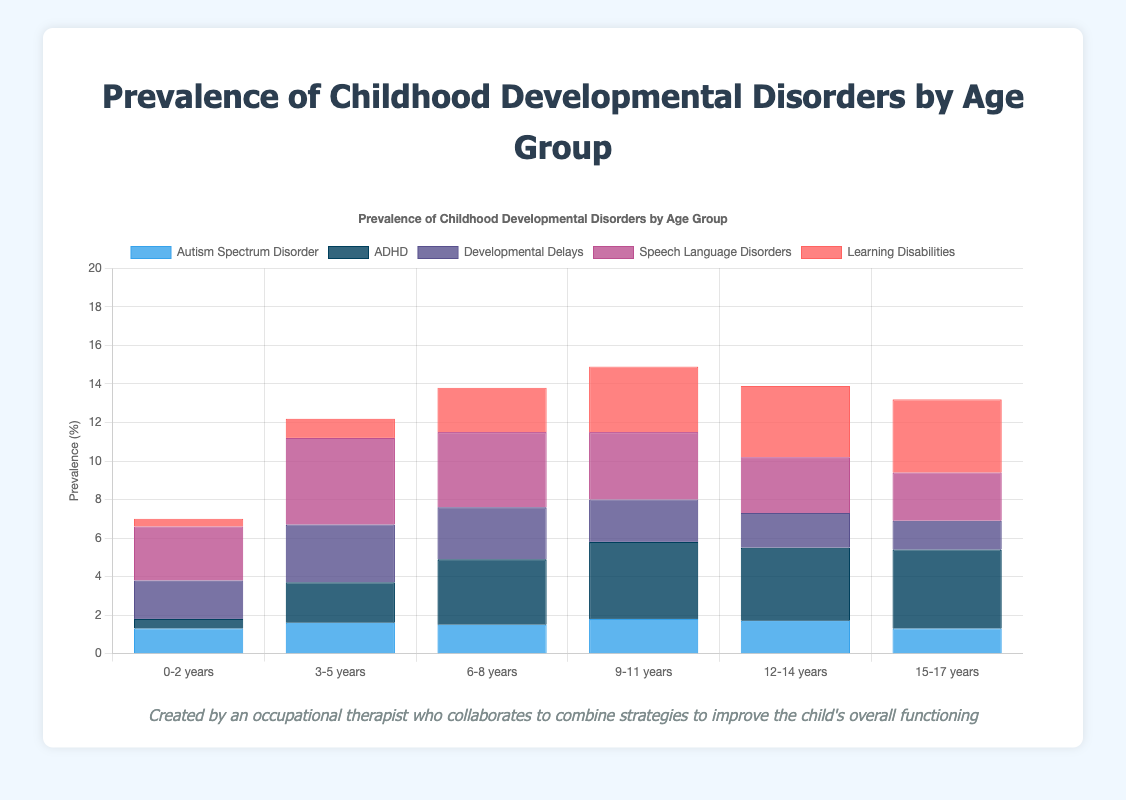What is the age group with the highest prevalence of ADHD? To determine the age group with the highest prevalence of ADHD, compare the data points for ADHD across all age groups. From the bar chart, the values are 0.5, 2.1, 3.4, 4.0, 3.8, and 4.1. The highest value is 4.1, which corresponds to the age group 15-17 years.
Answer: 15-17 years What is the total prevalence of learning disabilities across all age groups? To find the total prevalence, sum the values for learning disabilities across all age groups. The values are 0.4, 1.0, 2.3, 3.4, 3.7, and 3.8. The sum is 0.4 + 1.0 + 2.3 + 3.4 + 3.7 + 3.8 = 14.6.
Answer: 14.6 Which age group shows the least prevalence of developmental delays? Compare the values for developmental delays across all age groups. The values are 2.0, 3.0, 2.7, 2.2, 1.8, and 1.5. The smallest value is 1.5, which corresponds to the age group 15-17 years.
Answer: 15-17 years What is the average prevalence of Autism Spectrum Disorder across all age groups? To find the average prevalence, sum the values for Autism Spectrum Disorder and then divide by the number of age groups. The values are 1.3, 1.6, 1.5, 1.8, 1.7, and 1.3. The sum is 1.3 + 1.6 + 1.5 + 1.8 + 1.7 + 1.3 = 9.2. There are 6 age groups, so the average is 9.2 / 6 = 1.5333.
Answer: 1.53 Which developmental disorder has the highest prevalence in the age group 3-5 years? Compare the prevalence rates of all developmental disorders within the age group 3-5 years. The values for this group are: ASD 1.6, ADHD 2.1, Developmental Delays 3.0, Speech Language Disorders 4.5, Learning Disabilities 1.0. The highest value is 4.5, corresponding to Speech Language Disorders.
Answer: Speech Language Disorders Is the prevalence of ADHD greater than that of Autism Spectrum Disorder in the age group 9-11 years? Compare the values of ADHD and Autism Spectrum Disorder for the age group 9-11 years. The values are ADHD 4.0 and Autism Spectrum Disorder 1.8. Since 4.0 is greater than 1.8, the answer is yes.
Answer: yes What is the combined prevalence of speech language disorders and developmental delays in the age group 0-2 years? Add the prevalence values of speech language disorders and developmental delays for the age group 0-2 years. The values are Speech Language Disorders 2.8 and Developmental Delays 2.0. The sum is 2.8 + 2.0 = 4.8.
Answer: 4.8 Which age group has a higher prevalence of learning disabilities, 12-14 years or 15-17 years? Compare the learning disabilities values for the age groups 12-14 years and 15-17 years. The values are 12-14 years 3.7 and 15-17 years 3.8. Since 3.8 is greater than 3.7, the age group 15-17 years has a higher prevalence.
Answer: 15-17 years 